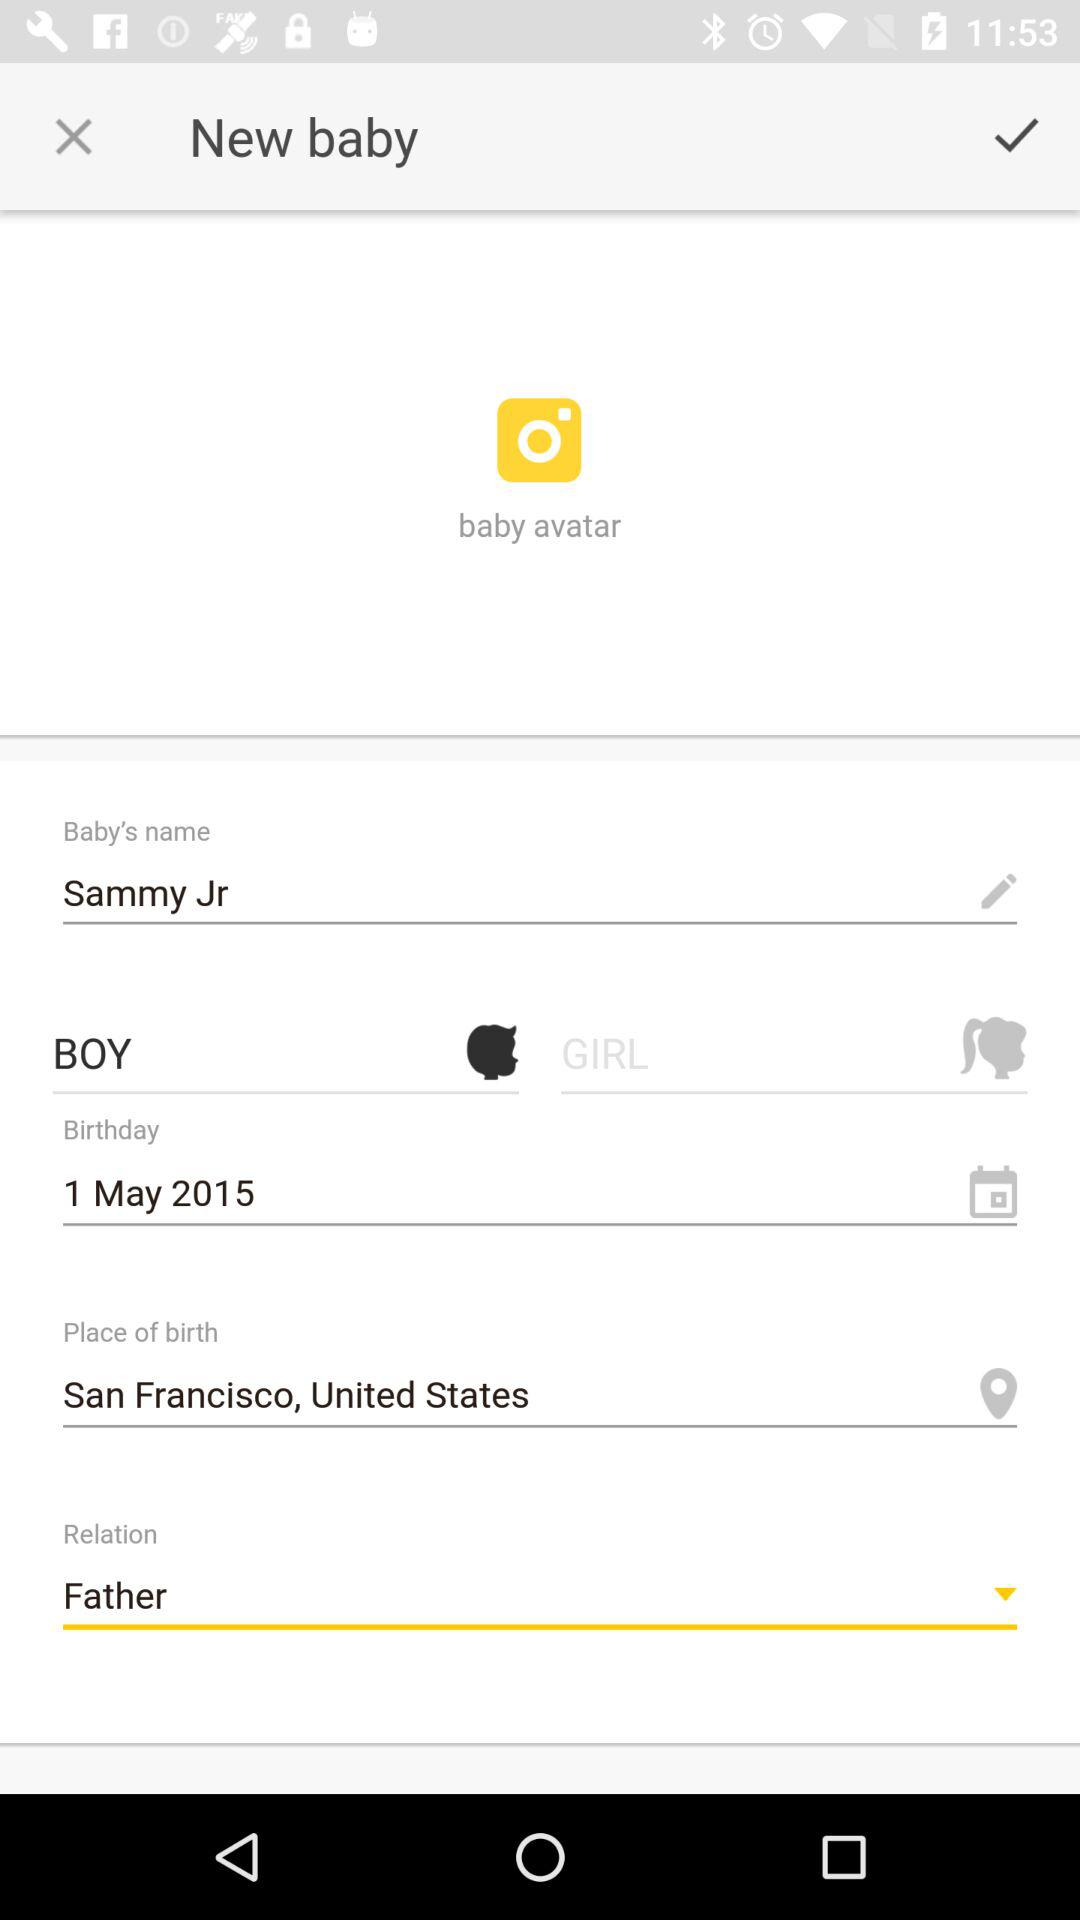What is the relation betwen I and baby?
When the provided information is insufficient, respond with <no answer>. <no answer> 